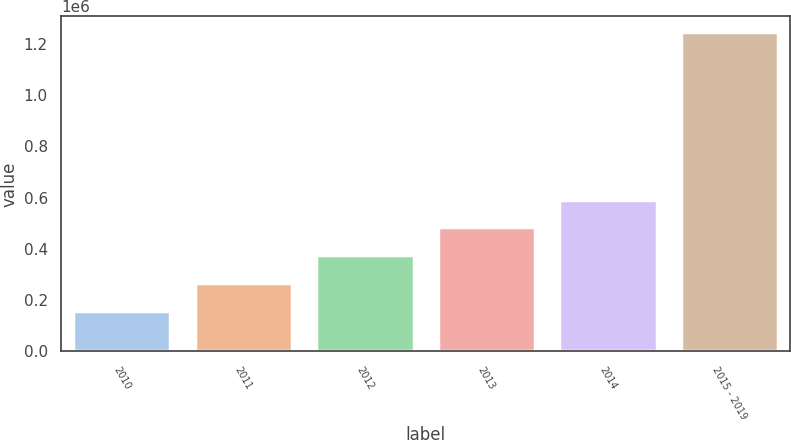<chart> <loc_0><loc_0><loc_500><loc_500><bar_chart><fcel>2010<fcel>2011<fcel>2012<fcel>2013<fcel>2014<fcel>2015 - 2019<nl><fcel>157279<fcel>266047<fcel>374815<fcel>483584<fcel>592352<fcel>1.24496e+06<nl></chart> 